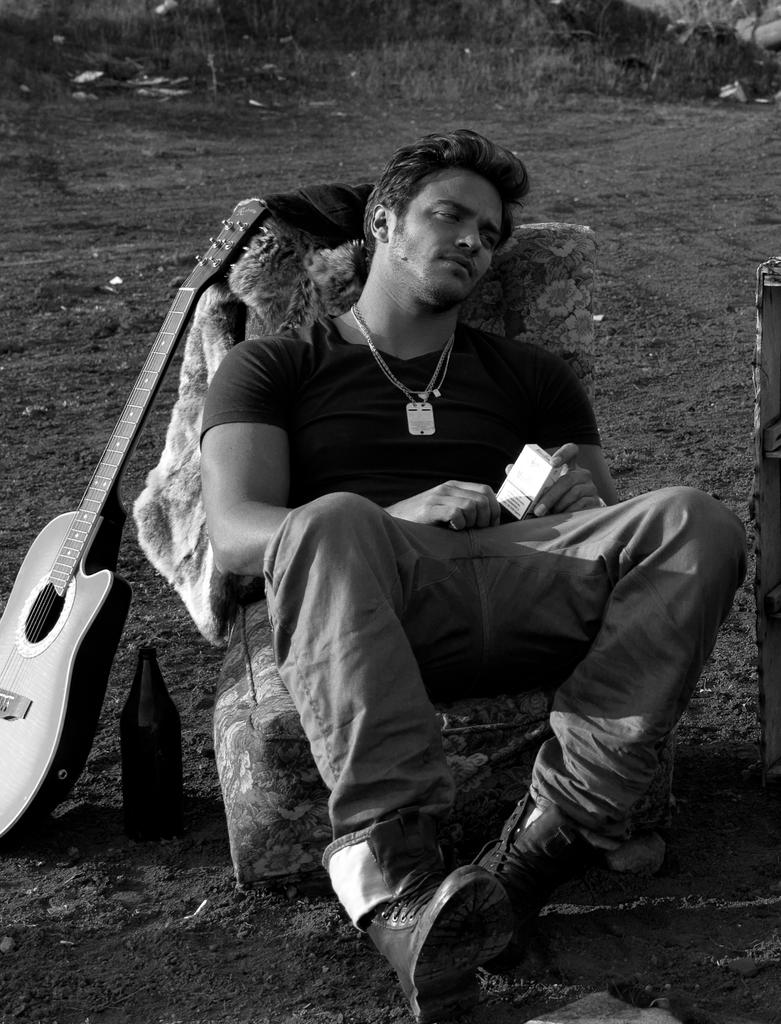Who is present in the image? There is a man in the image. What is the man doing in the image? The man is sitting in the image. What object is near the man? There is a guitar next to the man. What is the man holding in the image? The man is holding a box in his hands. What color is the man's tongue in the image? There is no information about the man's tongue in the image, so we cannot determine its color. 